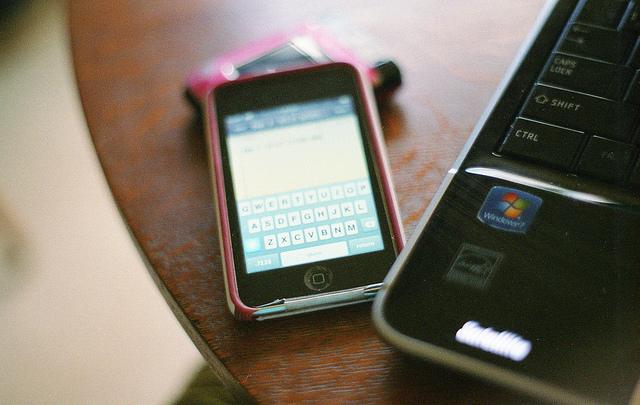Are both of these phones taking a picture?
Be succinct. No. Who is holding the phone?
Keep it brief. No one. Is this a smartphone?
Answer briefly. Yes. What is the screen showing in the background?
Short answer required. Text. What is the person currently doing with the phone?
Concise answer only. Texting. Where is this phone?
Quick response, please. Table. Which phone is larger?
Keep it brief. Iphone. What color is the phone's case?
Write a very short answer. Pink. Is the phone setting on the table?
Give a very brief answer. Yes. Who was this person texting?
Keep it brief. Friend. What color is the floor?
Give a very brief answer. White. How many hands are in the photo?
Short answer required. 0. What color is the phone?
Write a very short answer. Red. What version of Windows came with this computer?
Write a very short answer. 7. What does the button say at the top of the phone?
Concise answer only. Microsoft. Are these objects in a safe position on the table?
Write a very short answer. No. What brand is this phone?
Be succinct. Apple. Is this  smartphone?
Concise answer only. Yes. Are the screens on?
Quick response, please. Yes. 